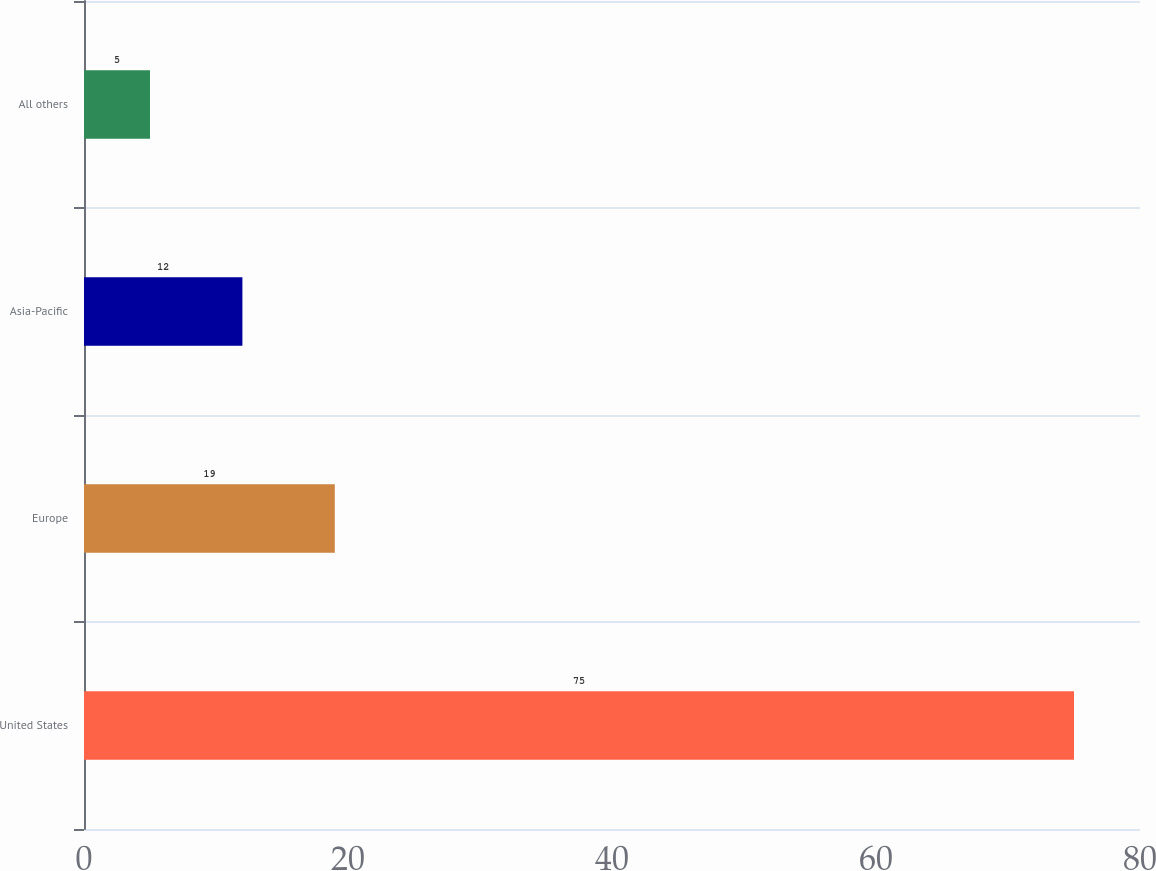Convert chart. <chart><loc_0><loc_0><loc_500><loc_500><bar_chart><fcel>United States<fcel>Europe<fcel>Asia-Pacific<fcel>All others<nl><fcel>75<fcel>19<fcel>12<fcel>5<nl></chart> 